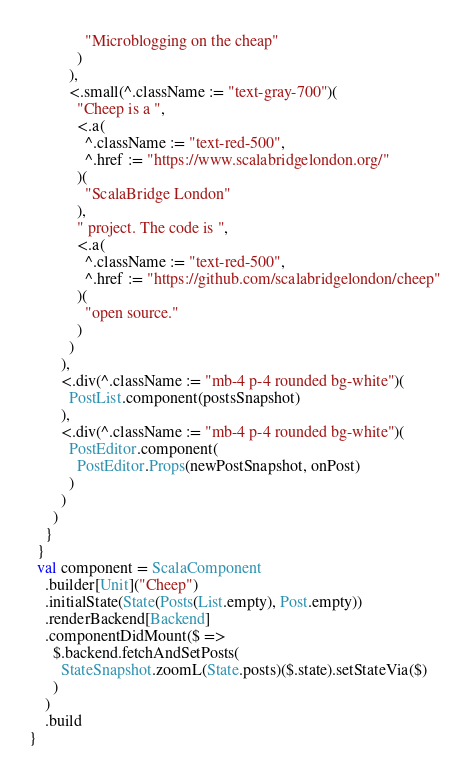<code> <loc_0><loc_0><loc_500><loc_500><_Scala_>              "Microblogging on the cheap"
            )
          ),
          <.small(^.className := "text-gray-700")(
            "Cheep is a ",
            <.a(
              ^.className := "text-red-500",
              ^.href := "https://www.scalabridgelondon.org/"
            )(
              "ScalaBridge London"
            ),
            " project. The code is ",
            <.a(
              ^.className := "text-red-500",
              ^.href := "https://github.com/scalabridgelondon/cheep"
            )(
              "open source."
            )
          )
        ),
        <.div(^.className := "mb-4 p-4 rounded bg-white")(
          PostList.component(postsSnapshot)
        ),
        <.div(^.className := "mb-4 p-4 rounded bg-white")(
          PostEditor.component(
            PostEditor.Props(newPostSnapshot, onPost)
          )
        )
      )
    }
  }
  val component = ScalaComponent
    .builder[Unit]("Cheep")
    .initialState(State(Posts(List.empty), Post.empty))
    .renderBackend[Backend]
    .componentDidMount($ =>
      $.backend.fetchAndSetPosts(
        StateSnapshot.zoomL(State.posts)($.state).setStateVia($)
      )
    )
    .build
}
</code> 